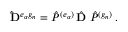<formula> <loc_0><loc_0><loc_500><loc_500>{ \hat { D } } ^ { e _ { \alpha } g _ { n } } = { \hat { P } } ^ { ( e _ { \alpha } ) } \, { \hat { D } } \, { \hat { P } } ^ { ( g _ { n } ) } \, .</formula> 